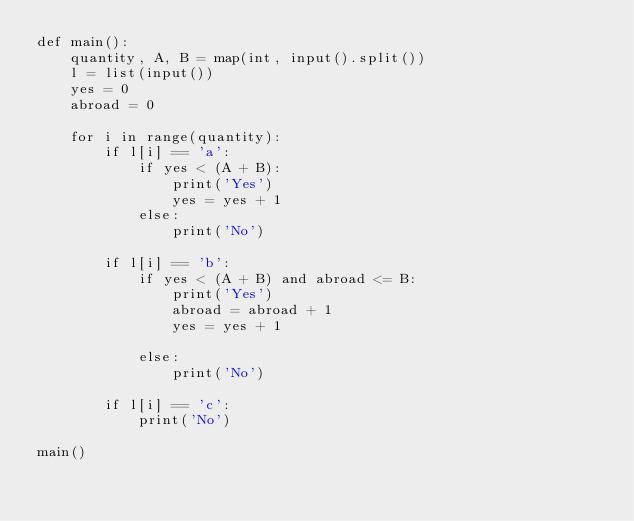<code> <loc_0><loc_0><loc_500><loc_500><_Python_>def main():
    quantity, A, B = map(int, input().split())
    l = list(input())
    yes = 0
    abroad = 0

    for i in range(quantity):
        if l[i] == 'a':
            if yes < (A + B):
                print('Yes')
                yes = yes + 1
            else:
                print('No')
        
        if l[i] == 'b':
            if yes < (A + B) and abroad <= B:
                print('Yes')
                abroad = abroad + 1
                yes = yes + 1

            else:
                print('No')
        
        if l[i] == 'c':
            print('No')

main()</code> 